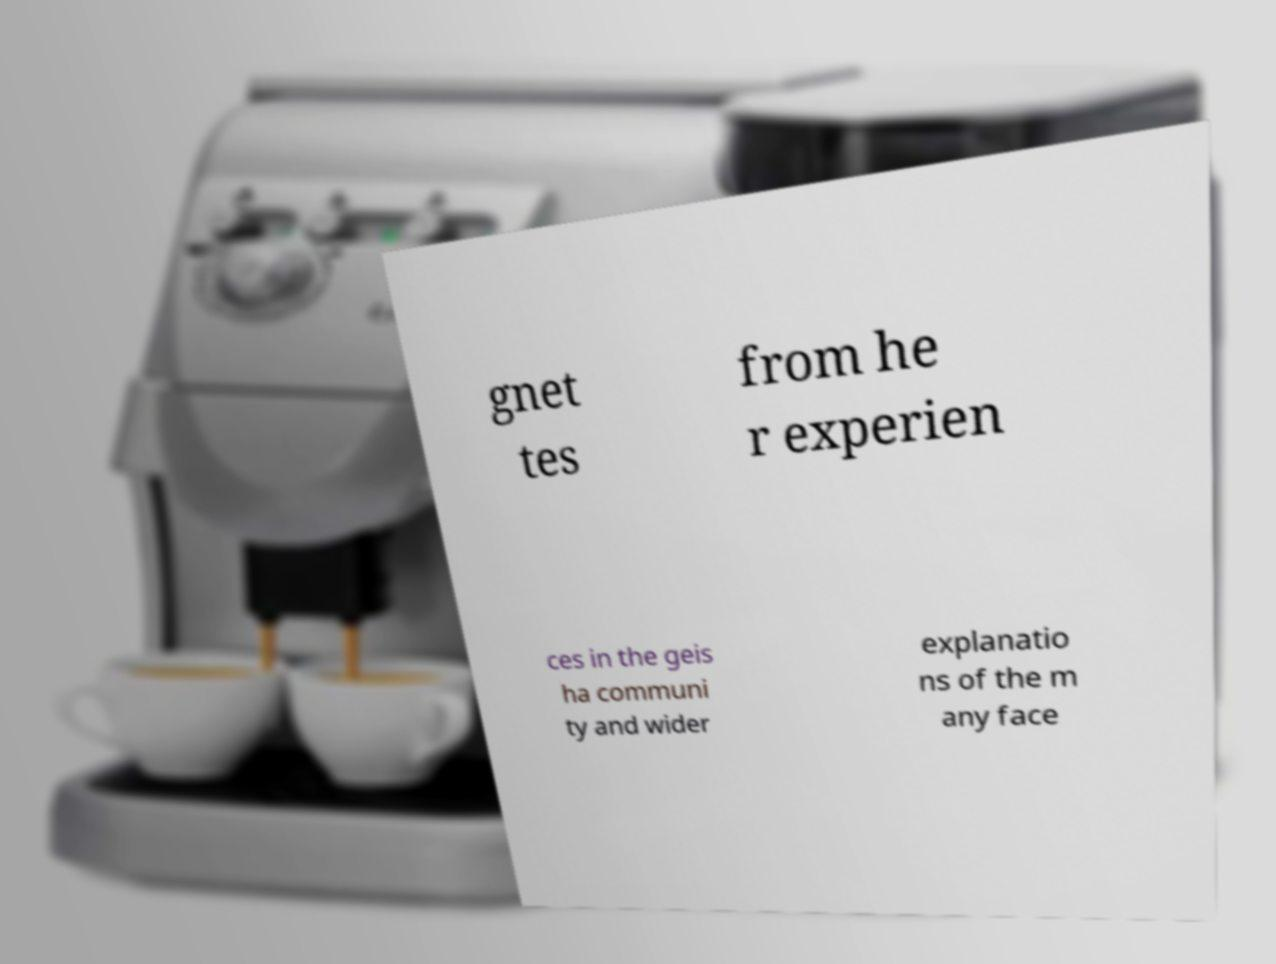There's text embedded in this image that I need extracted. Can you transcribe it verbatim? gnet tes from he r experien ces in the geis ha communi ty and wider explanatio ns of the m any face 